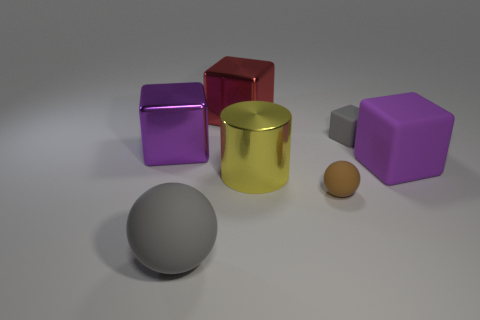Are there an equal number of gray rubber objects that are behind the big matte ball and metal blocks?
Your response must be concise. No. What number of objects are either purple blocks or cubes that are left of the brown matte ball?
Give a very brief answer. 3. Is the tiny matte block the same color as the big cylinder?
Your answer should be very brief. No. Is there a tiny object made of the same material as the big red cube?
Your answer should be compact. No. There is another rubber thing that is the same shape as the tiny gray rubber thing; what is its color?
Offer a terse response. Purple. Is the cylinder made of the same material as the large gray thing that is in front of the large yellow metal cylinder?
Give a very brief answer. No. The big yellow shiny thing behind the rubber ball that is left of the big red metal object is what shape?
Your answer should be compact. Cylinder. Is the size of the gray object left of the red cube the same as the yellow thing?
Offer a very short reply. Yes. What number of other objects are there of the same shape as the yellow shiny thing?
Provide a succinct answer. 0. Do the large metal cube on the left side of the big red shiny thing and the tiny matte ball have the same color?
Make the answer very short. No. 